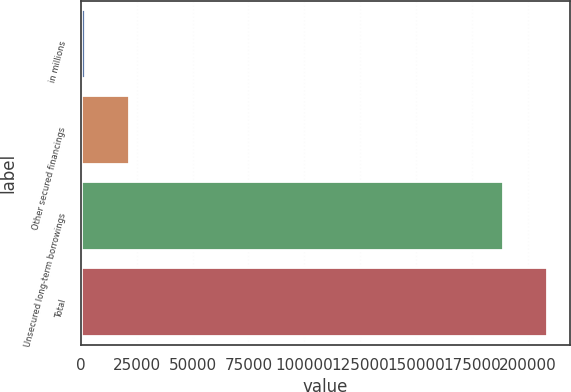Convert chart to OTSL. <chart><loc_0><loc_0><loc_500><loc_500><bar_chart><fcel>in millions<fcel>Other secured financings<fcel>Unsecured long-term borrowings<fcel>Total<nl><fcel>2016<fcel>21563.5<fcel>189086<fcel>208634<nl></chart> 